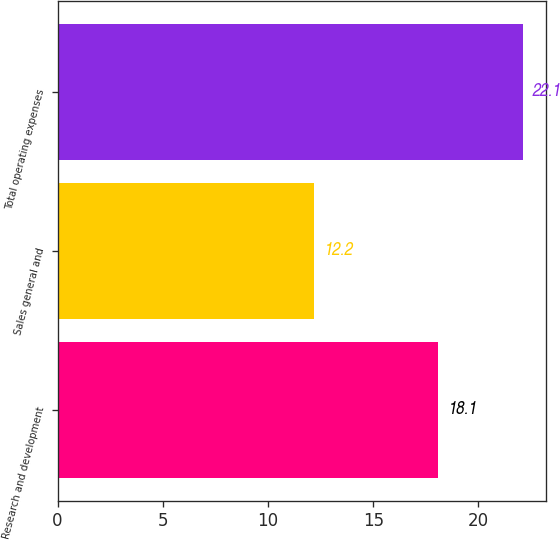Convert chart to OTSL. <chart><loc_0><loc_0><loc_500><loc_500><bar_chart><fcel>Research and development<fcel>Sales general and<fcel>Total operating expenses<nl><fcel>18.1<fcel>12.2<fcel>22.1<nl></chart> 